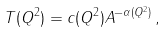Convert formula to latex. <formula><loc_0><loc_0><loc_500><loc_500>T ( Q ^ { 2 } ) = c ( Q ^ { 2 } ) A ^ { - \alpha ( Q ^ { 2 } ) } \, ,</formula> 